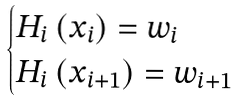<formula> <loc_0><loc_0><loc_500><loc_500>\begin{cases} H _ { i } \left ( x _ { i } \right ) = w _ { i } \\ H _ { i } \left ( x _ { i + 1 } \right ) = w _ { i + 1 } \end{cases}</formula> 